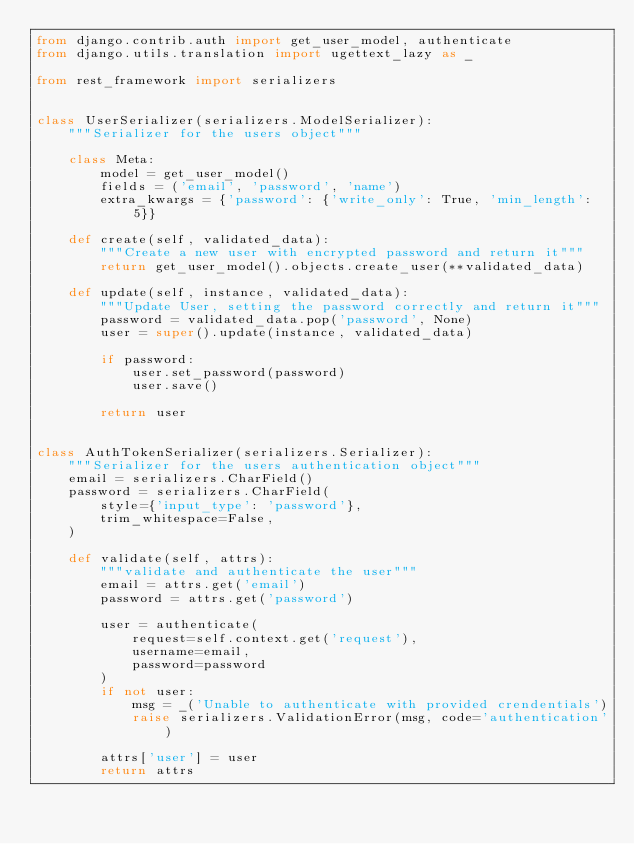<code> <loc_0><loc_0><loc_500><loc_500><_Python_>from django.contrib.auth import get_user_model, authenticate
from django.utils.translation import ugettext_lazy as _

from rest_framework import serializers


class UserSerializer(serializers.ModelSerializer):
    """Serializer for the users object"""

    class Meta:
        model = get_user_model()
        fields = ('email', 'password', 'name')
        extra_kwargs = {'password': {'write_only': True, 'min_length': 5}}

    def create(self, validated_data):
        """Create a new user with encrypted password and return it"""
        return get_user_model().objects.create_user(**validated_data)

    def update(self, instance, validated_data):
        """Update User, setting the password correctly and return it"""
        password = validated_data.pop('password', None)
        user = super().update(instance, validated_data)

        if password:
            user.set_password(password)
            user.save()

        return user


class AuthTokenSerializer(serializers.Serializer):
    """Serializer for the users authentication object"""
    email = serializers.CharField()
    password = serializers.CharField(
        style={'input_type': 'password'},
        trim_whitespace=False,
    )

    def validate(self, attrs):
        """validate and authenticate the user"""
        email = attrs.get('email')
        password = attrs.get('password')

        user = authenticate(
            request=self.context.get('request'),
            username=email,
            password=password
        )
        if not user:
            msg = _('Unable to authenticate with provided crendentials')
            raise serializers.ValidationError(msg, code='authentication')

        attrs['user'] = user
        return attrs
</code> 